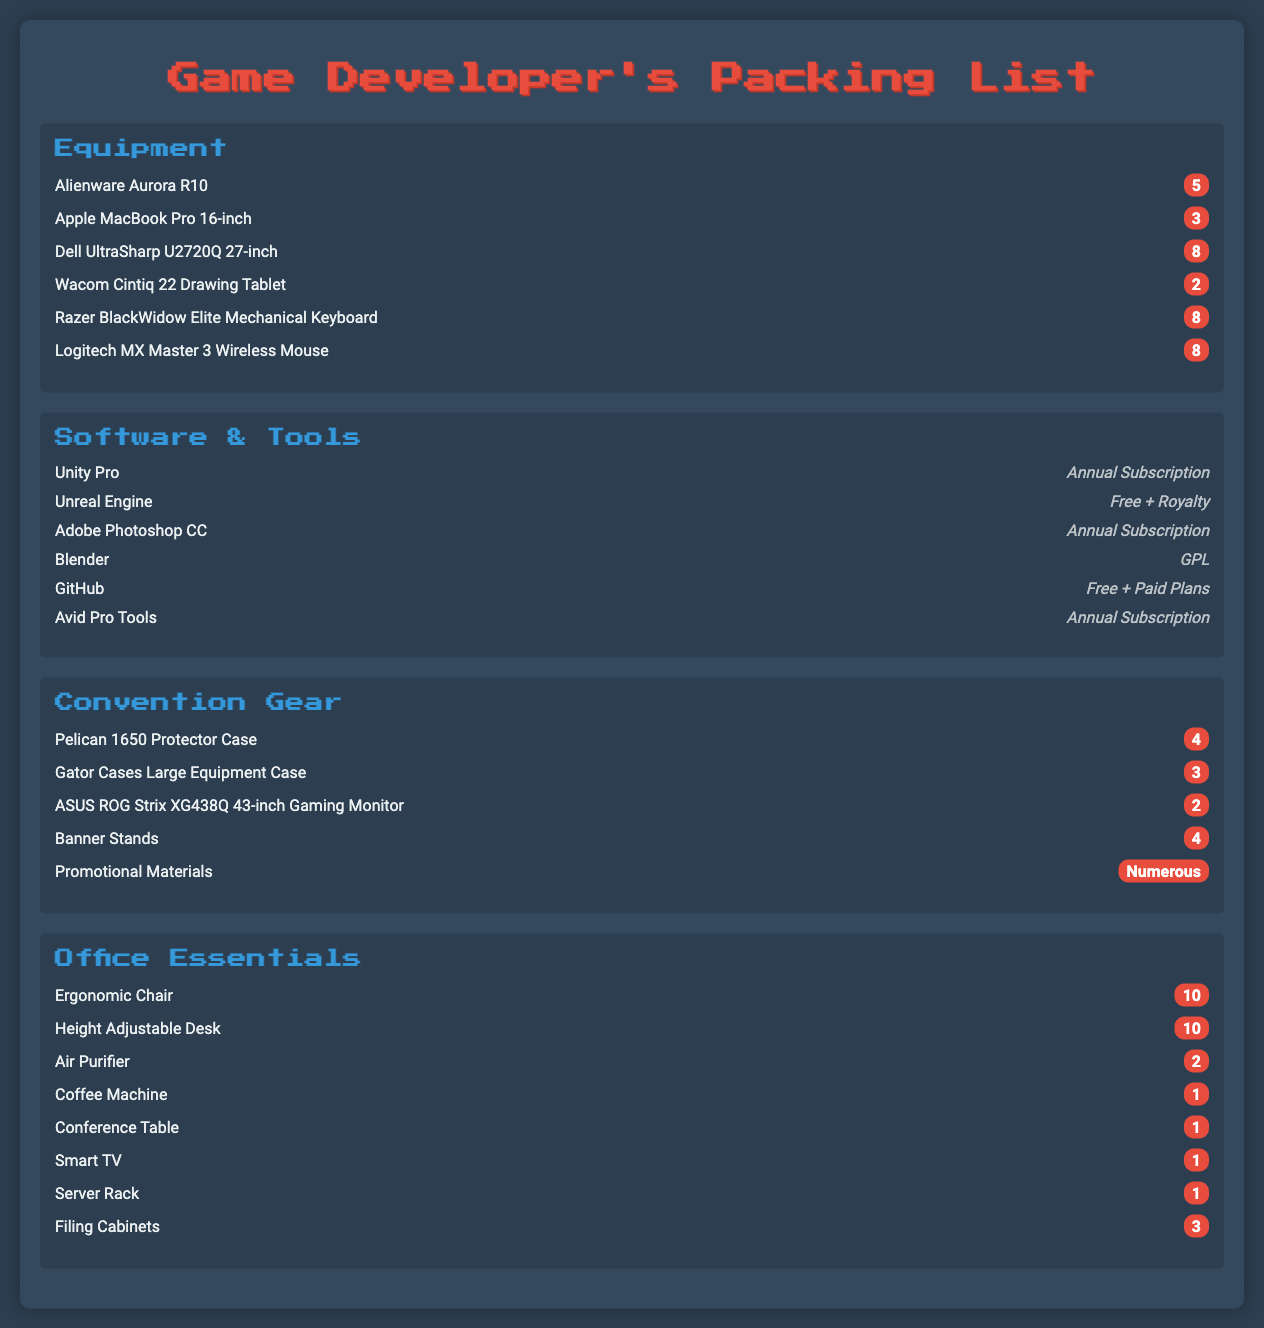What is the total quantity of Alienware Aurora R10? The total quantity is directly stated for each item in the Equipment section, which shows there are 5 units of Alienware Aurora R10.
Answer: 5 How many ergonomic chairs are listed under Office Essentials? The quantity for ergonomic chairs is provided in the Office Essentials section, which lists 10 ergonomic chairs.
Answer: 10 Which software has a GPL license? The Software & Tools section identifies Blender which is indicated as having a GPL license.
Answer: Blender What is the quantity of promotional materials mentioned? The document specifies that the quantity of promotional materials is numerous, indicating it is not a specific number.
Answer: Numerous How many different types of computers are included in the Equipment Inventory? Counting the items in the Equipment section shows there are 2 different types of computers: Alienware Aurora R10 and Apple MacBook Pro 16-inch.
Answer: 2 What item is included for air purification in the Office Essentials? The Office Essentials section lists an Air Purifier as one of the items.
Answer: Air Purifier How many Pelican 1650 Protector Cases are included in the Convention Gear? The document states that there are 4 Pelican 1650 Protector Cases included in Convention Gear section.
Answer: 4 What is the license type for Unity Pro software? The Software & Tools section specifies that Unity Pro is available under an Annual Subscription license.
Answer: Annual Subscription Which equipment case has a higher quantity, Pelican 1650 or Gator Cases? The comparison of quantities in the Convention Gear section shows Pelican 1650 cases total 4 whereas Gator Cases total 3, indicating Pelican 1650 has a higher quantity.
Answer: Pelican 1650 